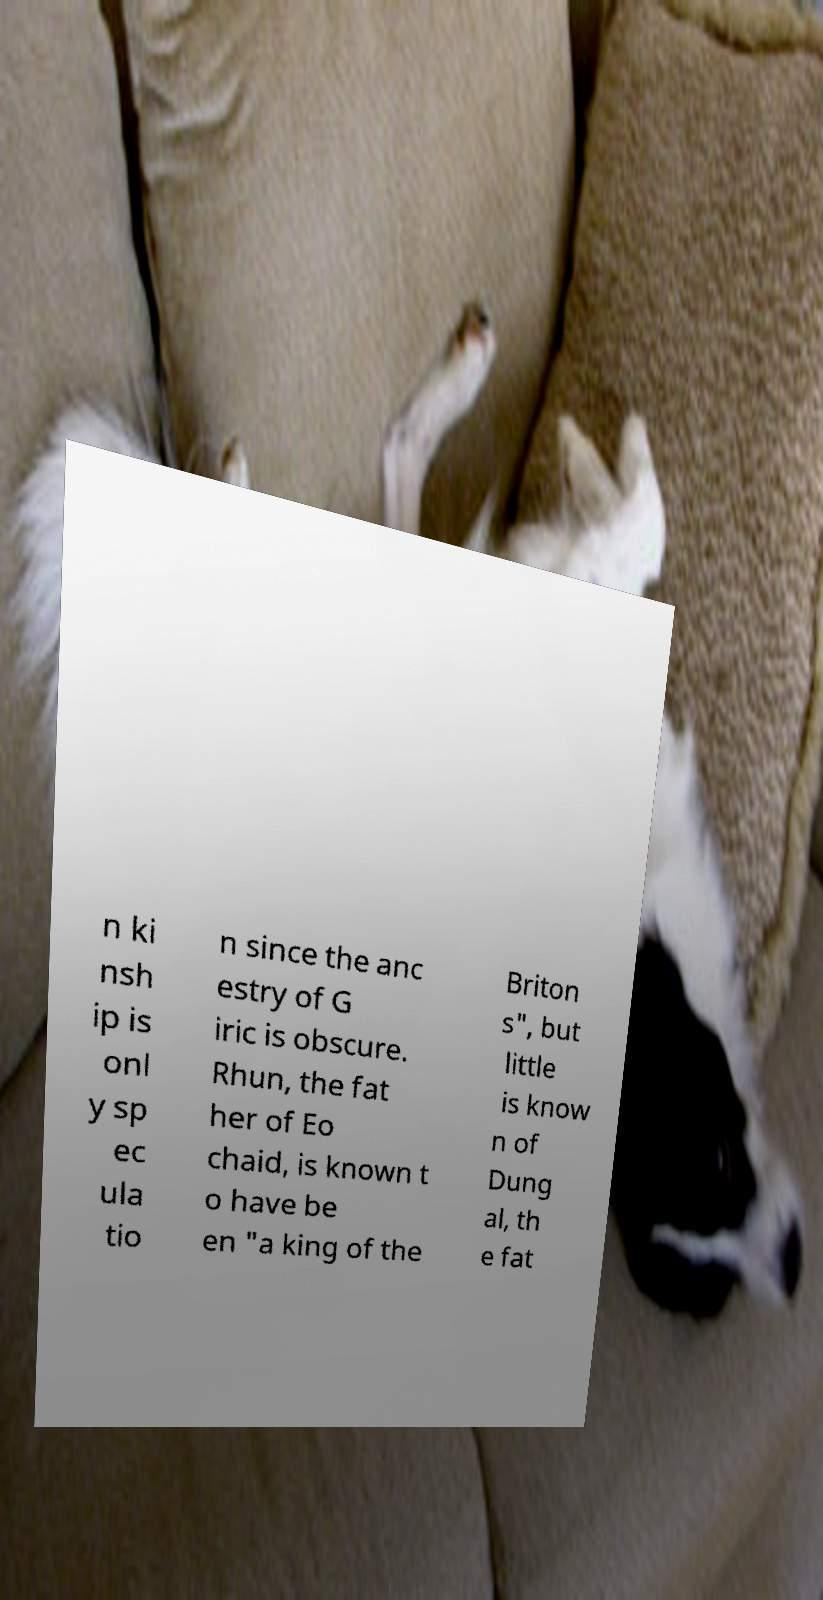Could you assist in decoding the text presented in this image and type it out clearly? n ki nsh ip is onl y sp ec ula tio n since the anc estry of G iric is obscure. Rhun, the fat her of Eo chaid, is known t o have be en "a king of the Briton s", but little is know n of Dung al, th e fat 